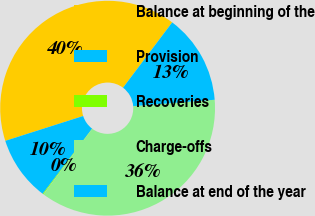Convert chart to OTSL. <chart><loc_0><loc_0><loc_500><loc_500><pie_chart><fcel>Balance at beginning of the<fcel>Provision<fcel>Recoveries<fcel>Charge-offs<fcel>Balance at end of the year<nl><fcel>40.18%<fcel>9.76%<fcel>0.12%<fcel>36.46%<fcel>13.48%<nl></chart> 